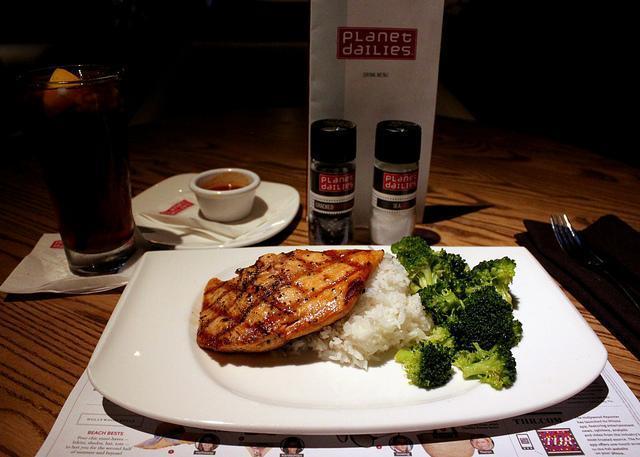How many bottles are in the photo?
Give a very brief answer. 2. 